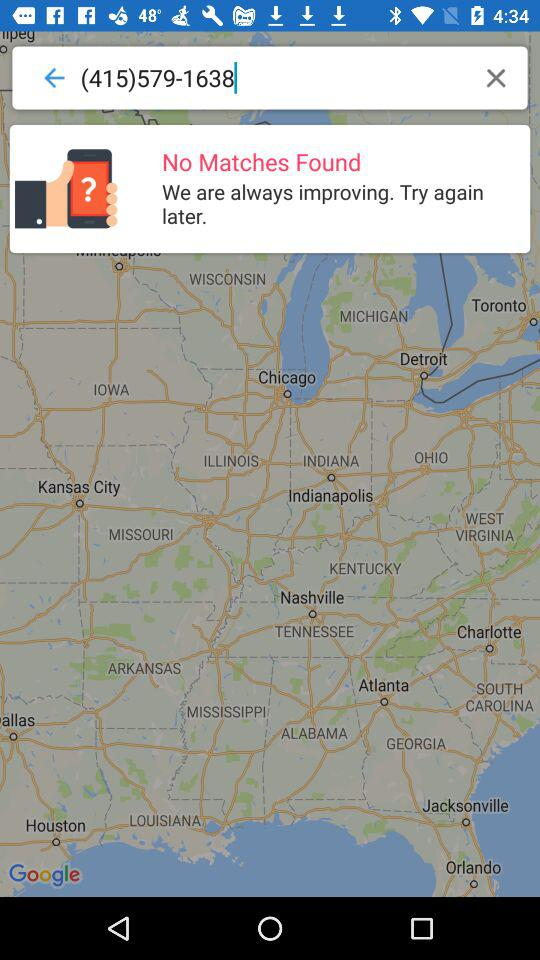What is the number in the search box? The number in the search box is (415)579-1638. 